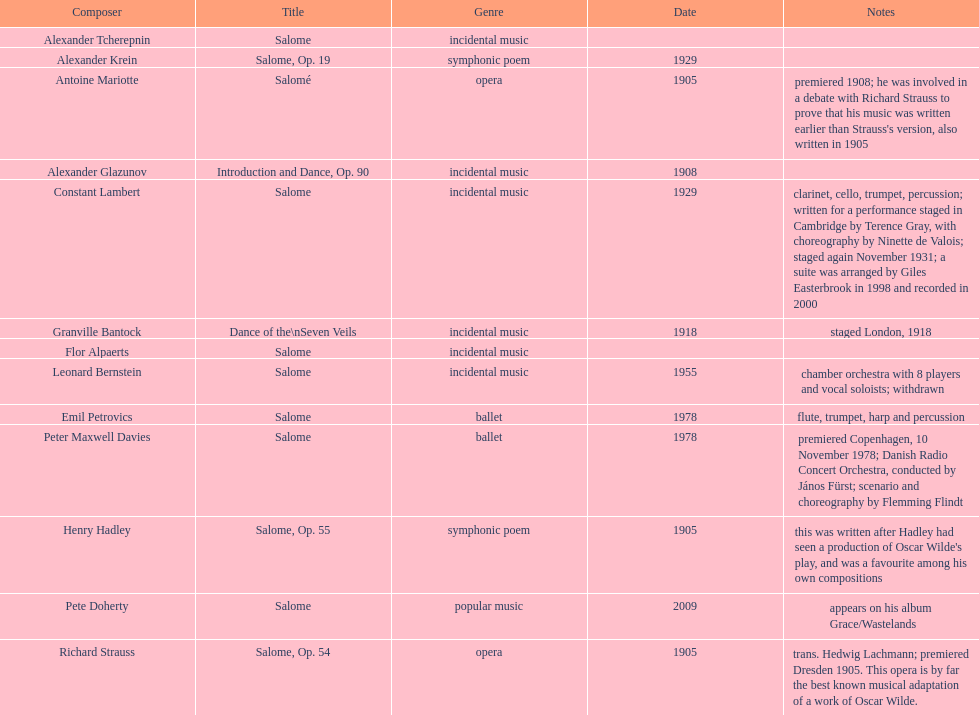What is the difference in years of granville bantock's work compared to pete dohert? 91. 